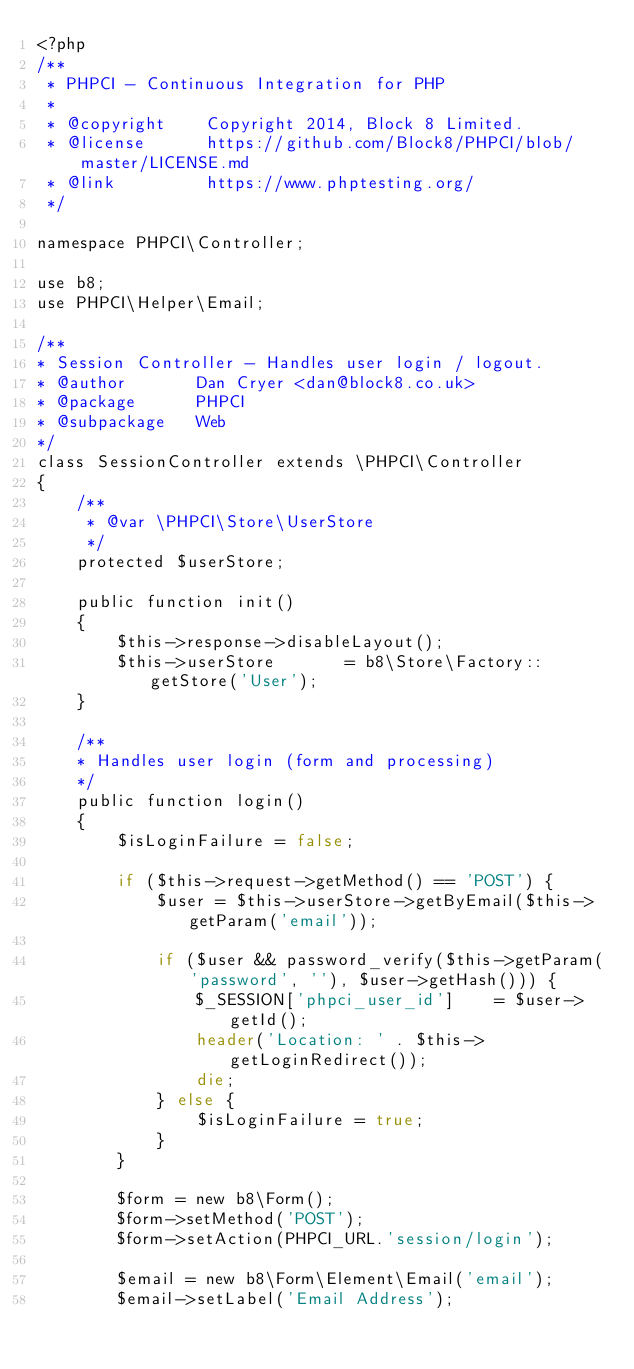Convert code to text. <code><loc_0><loc_0><loc_500><loc_500><_PHP_><?php
/**
 * PHPCI - Continuous Integration for PHP
 *
 * @copyright    Copyright 2014, Block 8 Limited.
 * @license      https://github.com/Block8/PHPCI/blob/master/LICENSE.md
 * @link         https://www.phptesting.org/
 */

namespace PHPCI\Controller;

use b8;
use PHPCI\Helper\Email;

/**
* Session Controller - Handles user login / logout.
* @author       Dan Cryer <dan@block8.co.uk>
* @package      PHPCI
* @subpackage   Web
*/
class SessionController extends \PHPCI\Controller
{
    /**
     * @var \PHPCI\Store\UserStore
     */
    protected $userStore;

    public function init()
    {
        $this->response->disableLayout();
        $this->userStore       = b8\Store\Factory::getStore('User');
    }

    /**
    * Handles user login (form and processing)
    */
    public function login()
    {
        $isLoginFailure = false;

        if ($this->request->getMethod() == 'POST') {
            $user = $this->userStore->getByEmail($this->getParam('email'));

            if ($user && password_verify($this->getParam('password', ''), $user->getHash())) {
                $_SESSION['phpci_user_id']    = $user->getId();
                header('Location: ' . $this->getLoginRedirect());
                die;
            } else {
                $isLoginFailure = true;
            }
        }

        $form = new b8\Form();
        $form->setMethod('POST');
        $form->setAction(PHPCI_URL.'session/login');

        $email = new b8\Form\Element\Email('email');
        $email->setLabel('Email Address');</code> 